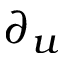Convert formula to latex. <formula><loc_0><loc_0><loc_500><loc_500>\partial _ { u }</formula> 